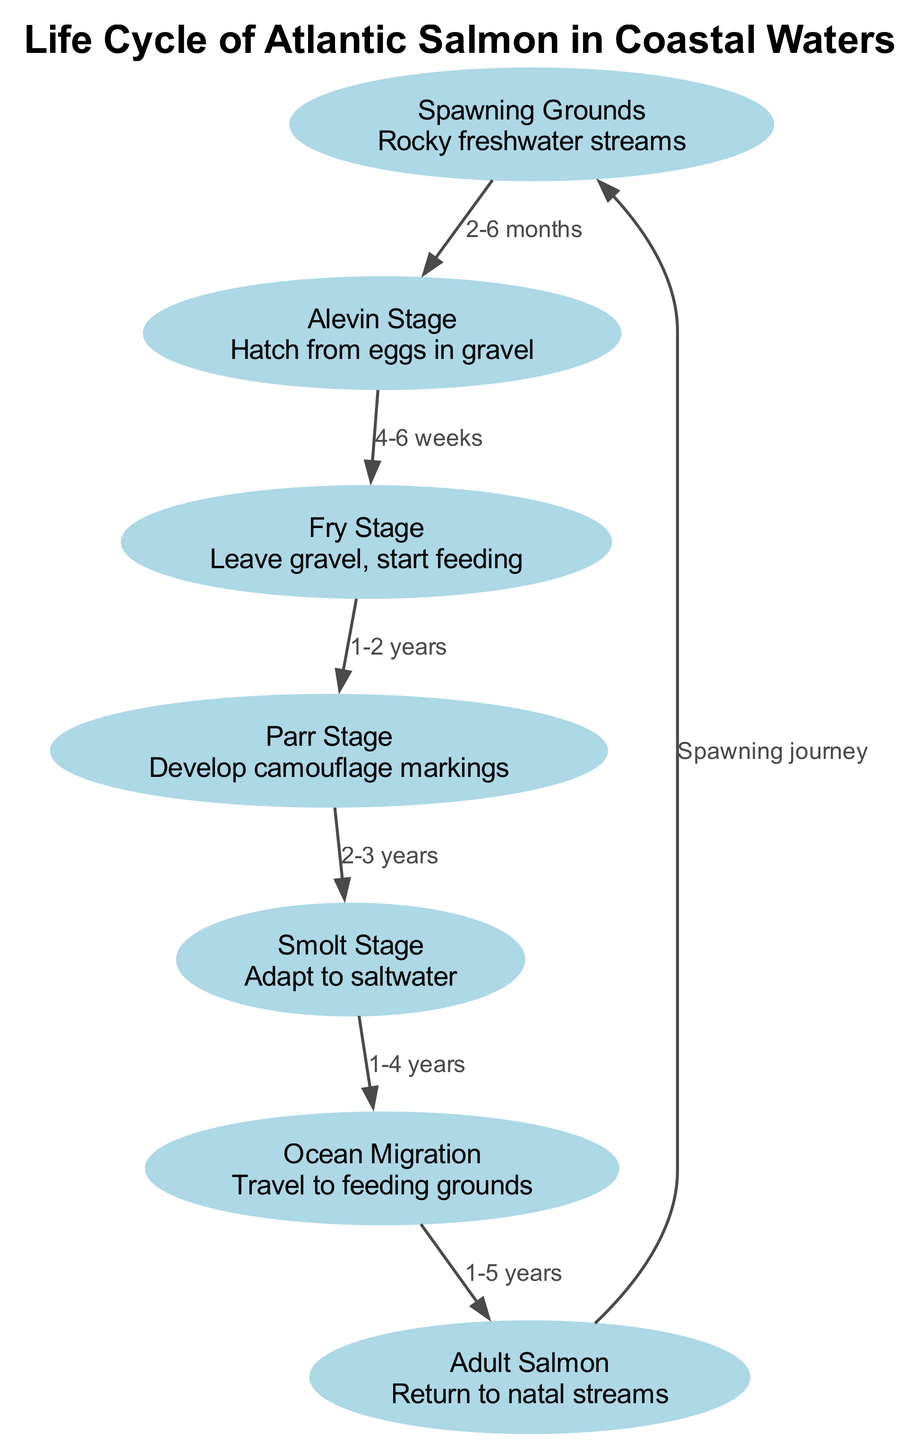What are the spawning grounds for the Atlantic Salmon? The diagram identifies "Spawning Grounds" located in "Rocky freshwater streams" as the starting point for the life cycle of the Atlantic Salmon.
Answer: Rocky freshwater streams How long does the Alevin stage last? The edge from the "Spawning Grounds" to the "Alevin Stage" indicates a duration of "2-6 months" for the Alevin stage after hatching from eggs.
Answer: 2-6 months What stage follows the Fry stage? The diagram shows that after the "Fry Stage," the next stage in the life cycle is the "Parr Stage."
Answer: Parr Stage How many total stages are represented in the diagram? By counting each distinct node in the diagram, there are a total of 7 stages representing the life cycle of the Atlantic Salmon.
Answer: 7 What is the migration duration to the ocean after the Smolt stage? The edge from the "Smolt Stage" to "Ocean Migration" indicates that the duration for this migration can last "1-4 years."
Answer: 1-4 years Which stage develops camouflage markings? According to the description associated with the "Parr Stage," this is where the fish develops camouflage markings as part of its growth process.
Answer: Parr Stage What is the relationship between the Adult Salmon and the Spawning Grounds? The diagram shows a cycle where the "Adult Salmon" returns to the "Spawning Grounds," which is labeled as a "Spawning journey," indicating their reproductive behavior.
Answer: Spawning journey What is the total time from Alevin to Adult Salmon? By adding the durations through each stage, we have 2-6 months (Alevin) + 4-6 weeks (Fry) + 1-2 years (Parr) + 2-3 years (Smolt) + 1-5 years (Ocean migration). This sums up to a total range from approximately 4 years to over 11 years from Alevin to Adult Salmon.
Answer: 4-11 years 